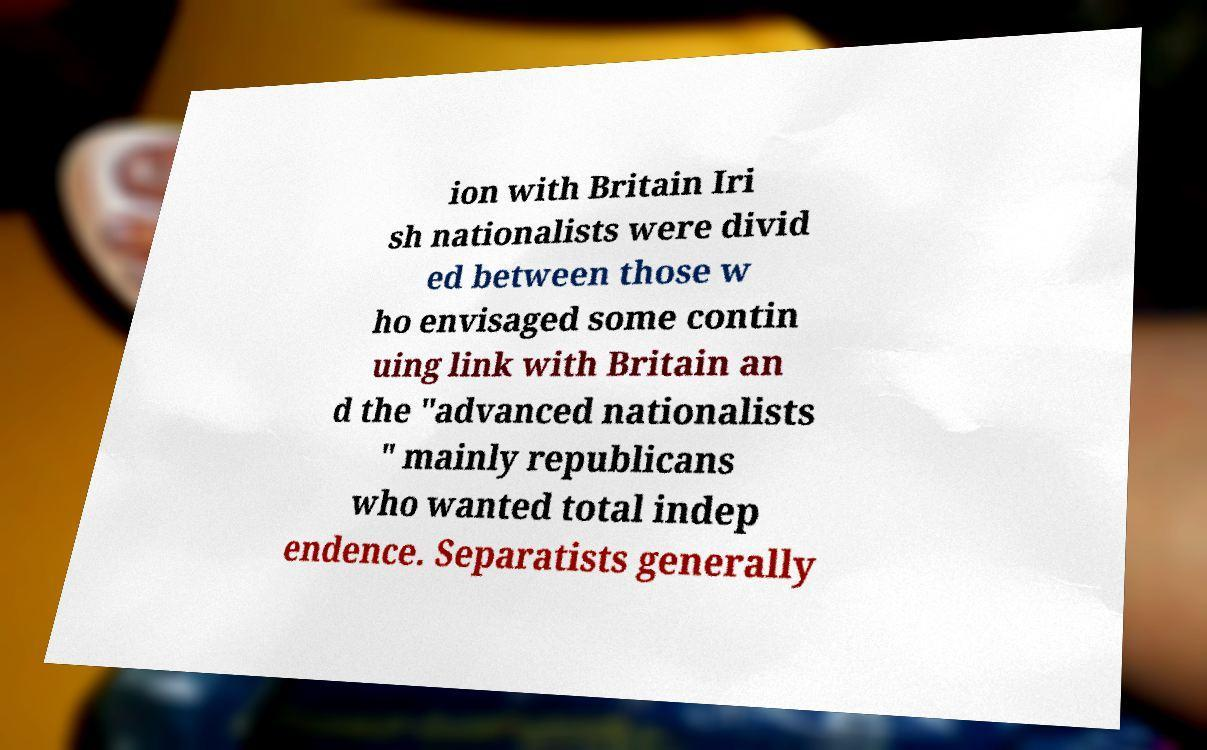Can you read and provide the text displayed in the image?This photo seems to have some interesting text. Can you extract and type it out for me? ion with Britain Iri sh nationalists were divid ed between those w ho envisaged some contin uing link with Britain an d the "advanced nationalists " mainly republicans who wanted total indep endence. Separatists generally 